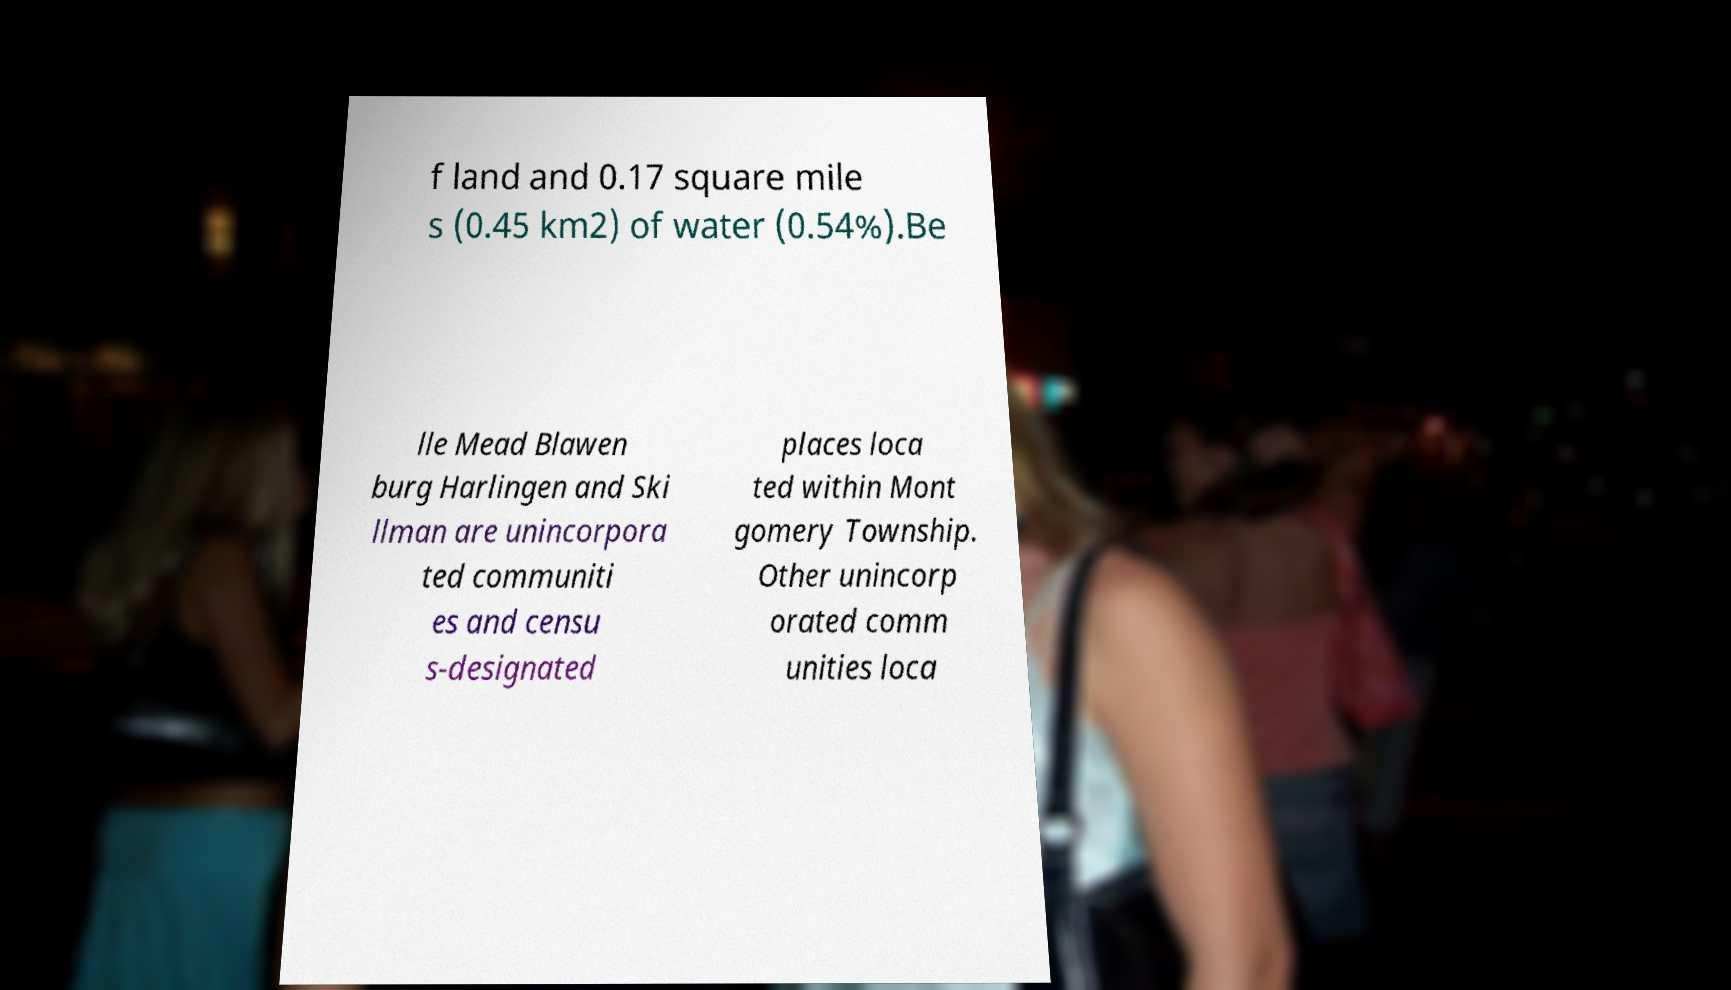There's text embedded in this image that I need extracted. Can you transcribe it verbatim? f land and 0.17 square mile s (0.45 km2) of water (0.54%).Be lle Mead Blawen burg Harlingen and Ski llman are unincorpora ted communiti es and censu s-designated places loca ted within Mont gomery Township. Other unincorp orated comm unities loca 